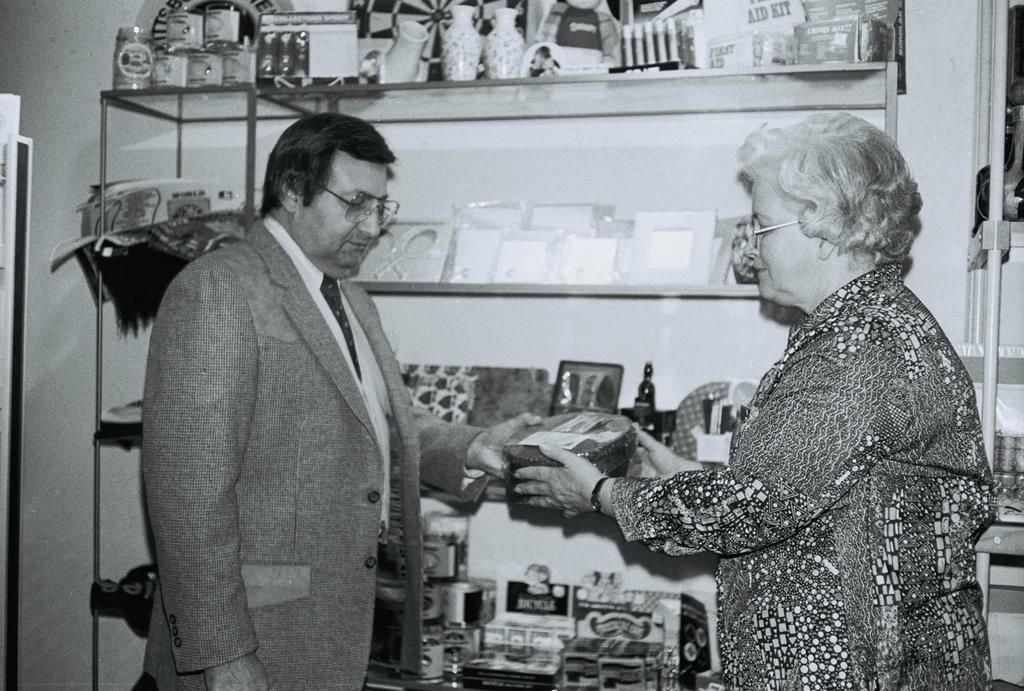How many people are in the image? Two persons are standing in the middle of the image. What are the persons holding in the image? The persons are holding a box. What is located beside the persons? There is a wall beside the persons. What can be seen on the wall? There are products and frames on the wall. What type of kite is being flown by the persons in the image? There is no kite present in the image. What advice are the persons giving to each other in the image? There is no indication of any advice being given in the image. 